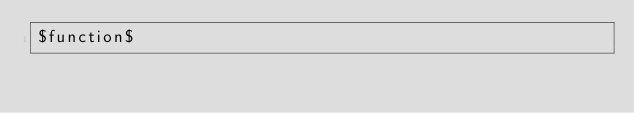Convert code to text. <code><loc_0><loc_0><loc_500><loc_500><_SQL_>$function$
</code> 